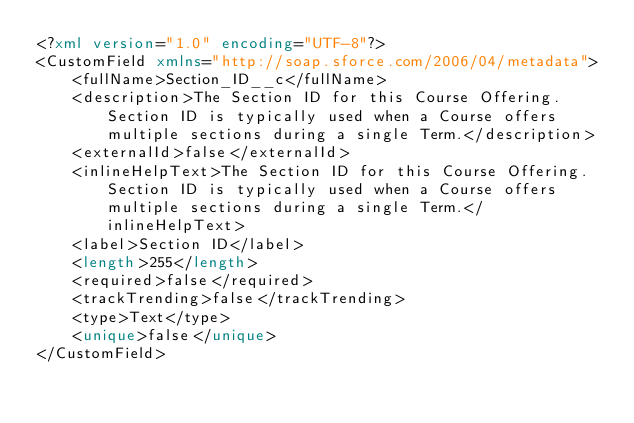<code> <loc_0><loc_0><loc_500><loc_500><_XML_><?xml version="1.0" encoding="UTF-8"?>
<CustomField xmlns="http://soap.sforce.com/2006/04/metadata">
    <fullName>Section_ID__c</fullName>
    <description>The Section ID for this Course Offering. Section ID is typically used when a Course offers multiple sections during a single Term.</description>
    <externalId>false</externalId>
    <inlineHelpText>The Section ID for this Course Offering. Section ID is typically used when a Course offers multiple sections during a single Term.</inlineHelpText>
    <label>Section ID</label>
    <length>255</length>
    <required>false</required>
    <trackTrending>false</trackTrending>
    <type>Text</type>
    <unique>false</unique>
</CustomField>
</code> 